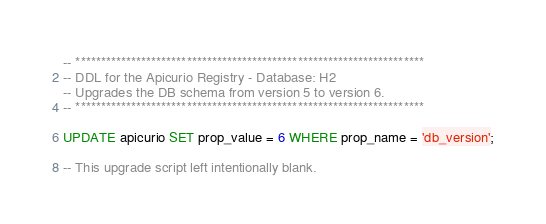<code> <loc_0><loc_0><loc_500><loc_500><_SQL_>-- *********************************************************************
-- DDL for the Apicurio Registry - Database: H2
-- Upgrades the DB schema from version 5 to version 6.
-- *********************************************************************

UPDATE apicurio SET prop_value = 6 WHERE prop_name = 'db_version';

-- This upgrade script left intentionally blank.
</code> 